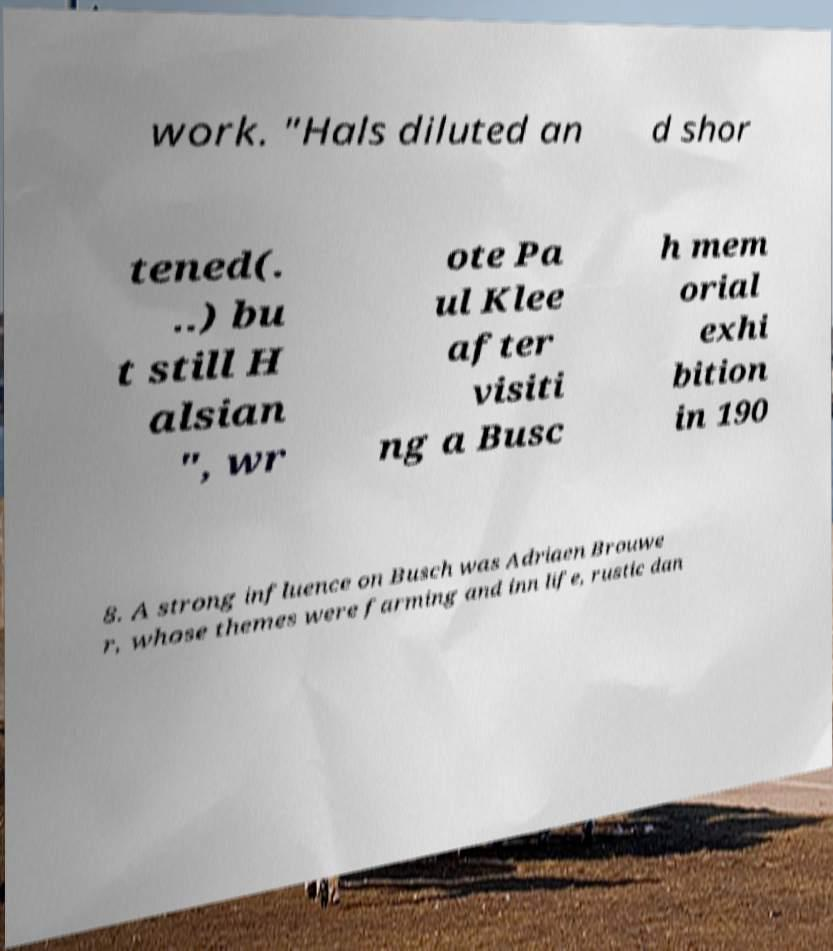For documentation purposes, I need the text within this image transcribed. Could you provide that? work. "Hals diluted an d shor tened(. ..) bu t still H alsian ", wr ote Pa ul Klee after visiti ng a Busc h mem orial exhi bition in 190 8. A strong influence on Busch was Adriaen Brouwe r, whose themes were farming and inn life, rustic dan 